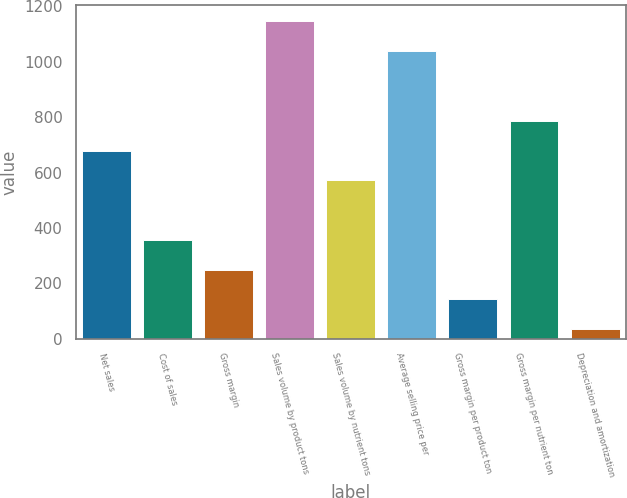Convert chart to OTSL. <chart><loc_0><loc_0><loc_500><loc_500><bar_chart><fcel>Net sales<fcel>Cost of sales<fcel>Gross margin<fcel>Sales volume by product tons<fcel>Sales volume by nutrient tons<fcel>Average selling price per<fcel>Gross margin per product ton<fcel>Gross margin per nutrient ton<fcel>Depreciation and amortization<nl><fcel>678.8<fcel>356.9<fcel>249.6<fcel>1147.3<fcel>571.5<fcel>1040<fcel>142.3<fcel>786.1<fcel>35<nl></chart> 